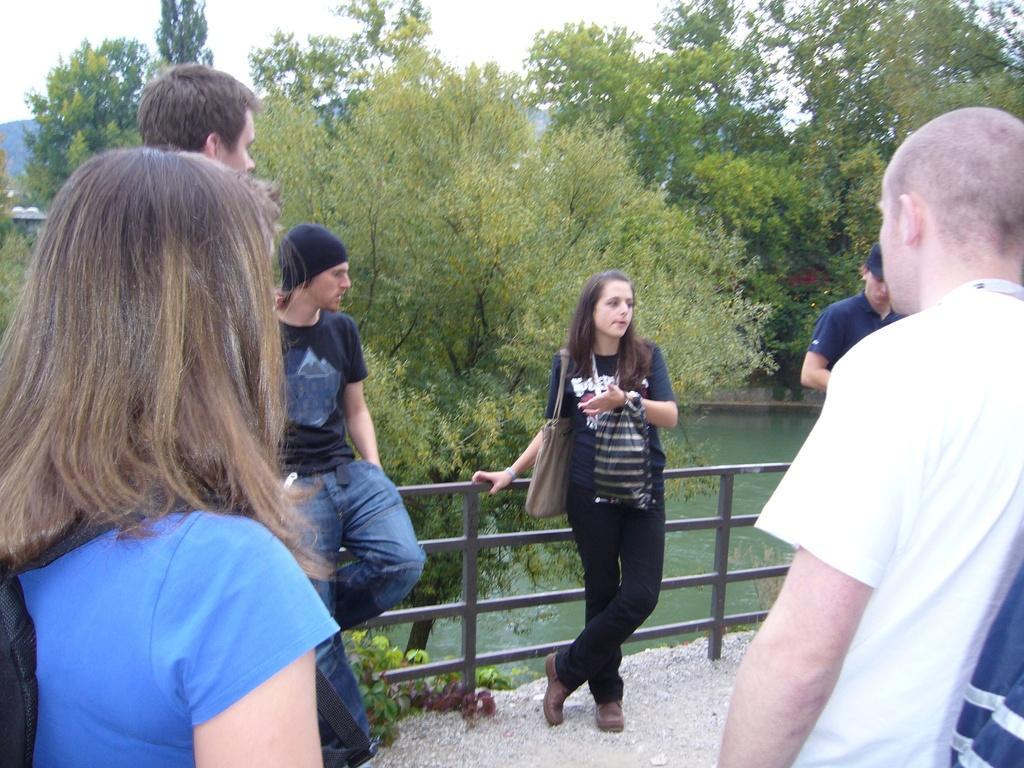In one or two sentences, can you explain what this image depicts? There are many people standing, this woman is having a golden gray color and she is wearing a blue t-shirt. This man wearing white t-shirt, this women is wearing blue t-shirt and a black pant there is a tree behind her and water. The sky is in white color. 